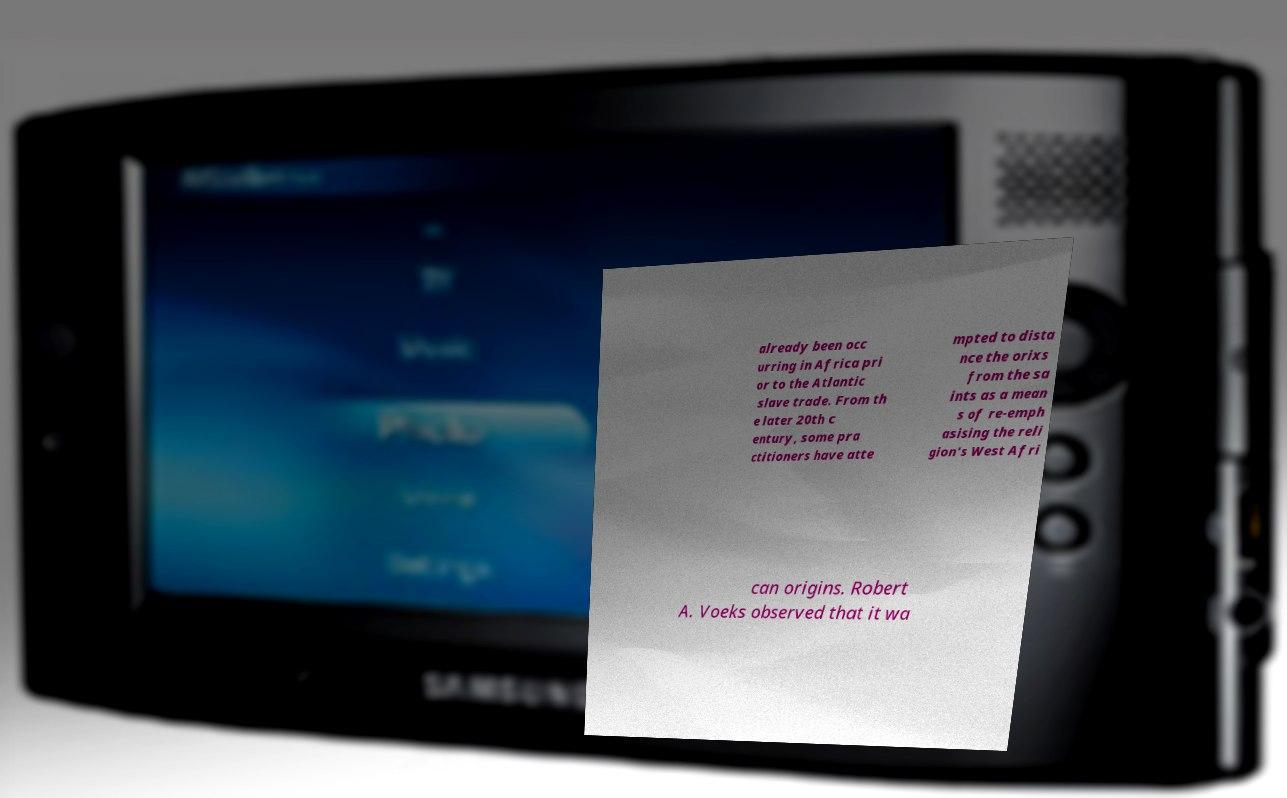Can you read and provide the text displayed in the image?This photo seems to have some interesting text. Can you extract and type it out for me? already been occ urring in Africa pri or to the Atlantic slave trade. From th e later 20th c entury, some pra ctitioners have atte mpted to dista nce the orixs from the sa ints as a mean s of re-emph asising the reli gion's West Afri can origins. Robert A. Voeks observed that it wa 